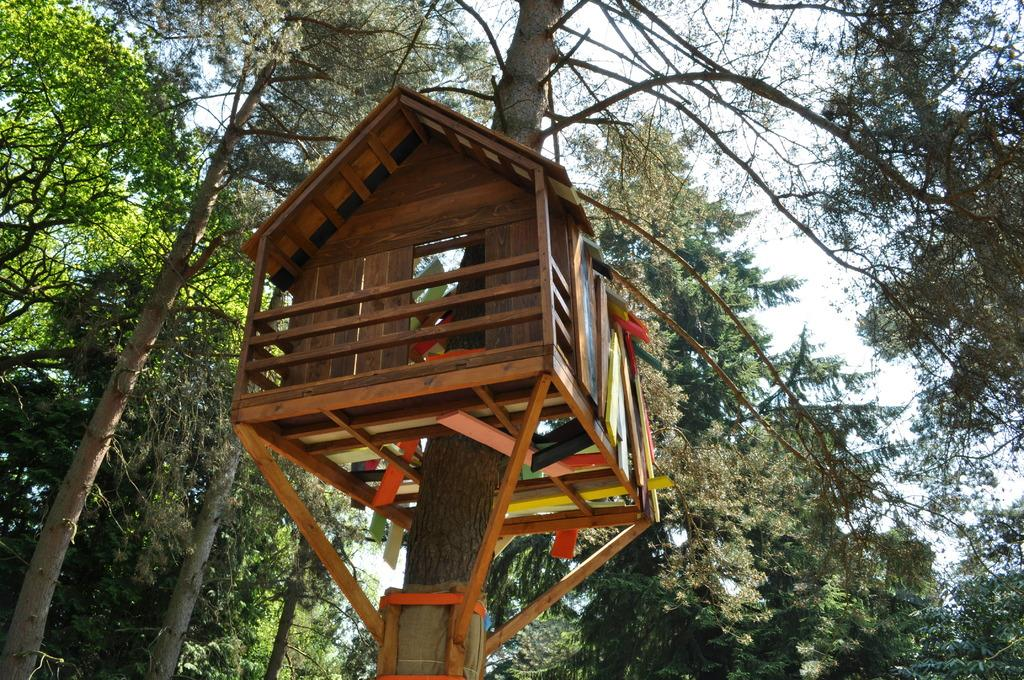What structure is featured in the image? There is a tree house in the image. What material is the tree house made of? The tree house is made of wood. What is the color of the wood used to build the tree house? The wood is brown in color. What type of vegetation is present in the image? There are trees in the image. What colors are the trees? The trees are green and brown in color. What can be seen in the background of the image? The sky is visible in the background of the image. Are there any giants visible in the image? No, there are no giants present in the image. What type of current is flowing through the tree house in the image? There is no current flowing through the tree house in the image, as it is a stationary structure. 